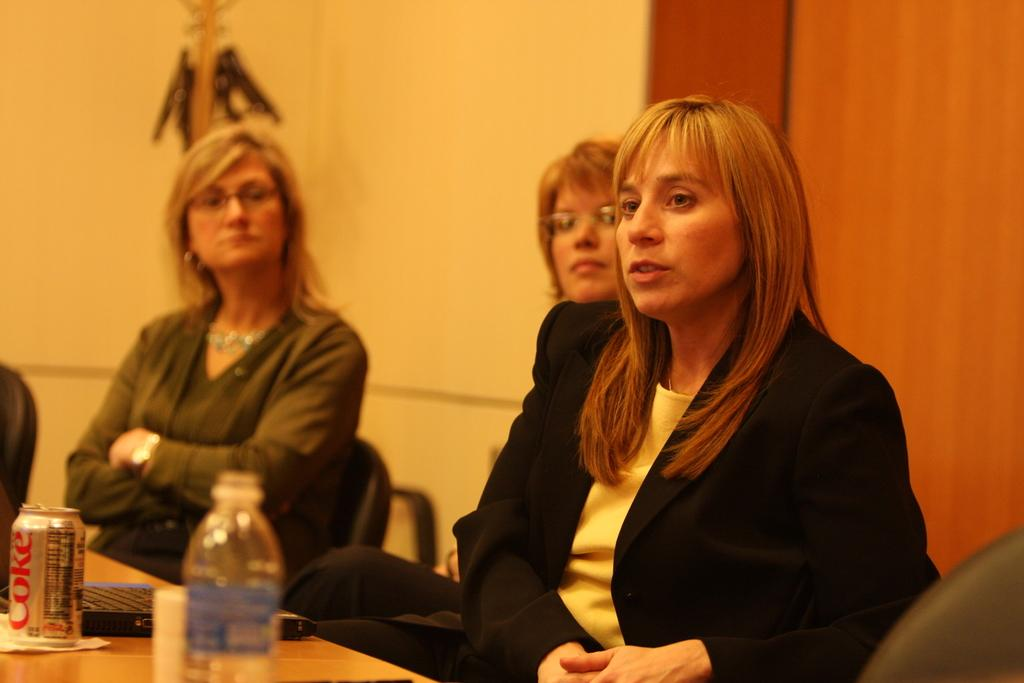How many women are sitting in the image? There are three women sitting in the image. What is in front of the women? The women have a table in front of them. What items can be seen on the table? There is a water bottle, a beverage can, and a second water bottle on the table. What is visible in the background of the image? There is a wall in the background of the image. How many girls are sitting in the image? The term "girls" is not accurate in this context, as the image features three adult women. Can you see any wounds on the women in the image? There is no indication of any wounds on the women in the image. 